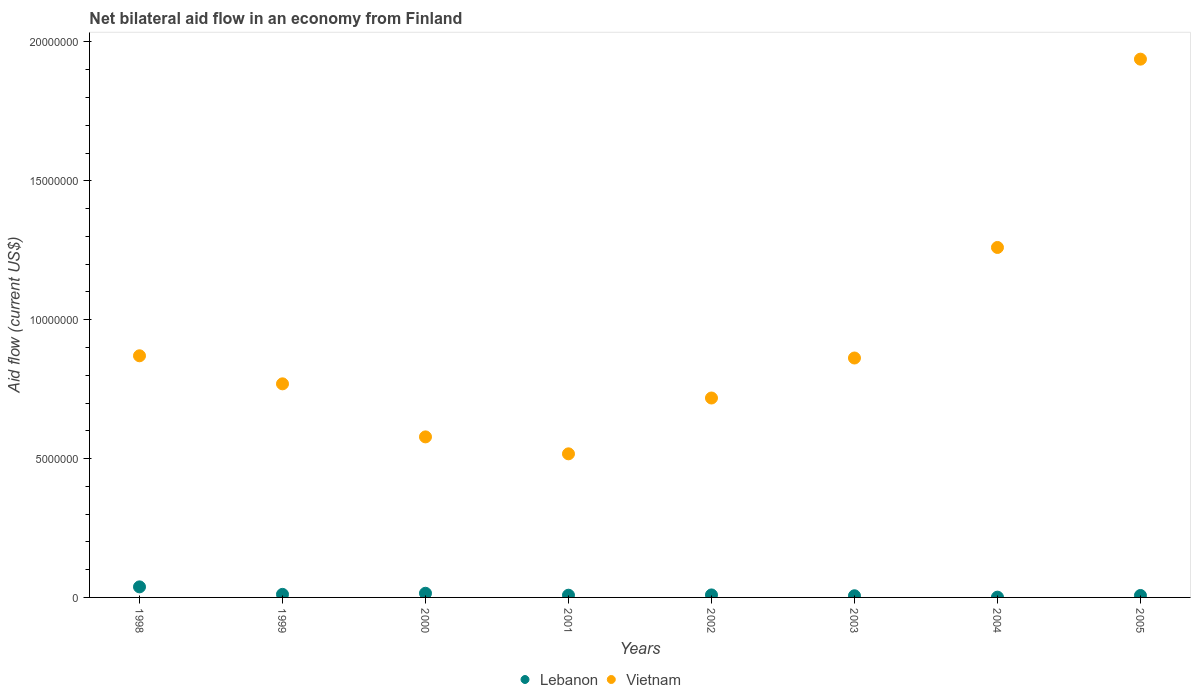How many different coloured dotlines are there?
Make the answer very short. 2. Is the number of dotlines equal to the number of legend labels?
Keep it short and to the point. Yes. What is the net bilateral aid flow in Lebanon in 1998?
Make the answer very short. 3.80e+05. Across all years, what is the maximum net bilateral aid flow in Vietnam?
Ensure brevity in your answer.  1.94e+07. What is the total net bilateral aid flow in Lebanon in the graph?
Your answer should be very brief. 9.50e+05. What is the difference between the net bilateral aid flow in Vietnam in 2001 and that in 2003?
Offer a very short reply. -3.45e+06. What is the difference between the net bilateral aid flow in Lebanon in 1998 and the net bilateral aid flow in Vietnam in 2002?
Offer a very short reply. -6.80e+06. What is the average net bilateral aid flow in Vietnam per year?
Offer a very short reply. 9.39e+06. In the year 2004, what is the difference between the net bilateral aid flow in Lebanon and net bilateral aid flow in Vietnam?
Provide a succinct answer. -1.26e+07. What is the ratio of the net bilateral aid flow in Vietnam in 1999 to that in 2005?
Ensure brevity in your answer.  0.4. Is the net bilateral aid flow in Lebanon in 1998 less than that in 2001?
Your response must be concise. No. Is the difference between the net bilateral aid flow in Lebanon in 1998 and 2001 greater than the difference between the net bilateral aid flow in Vietnam in 1998 and 2001?
Offer a terse response. No. Is the sum of the net bilateral aid flow in Vietnam in 1999 and 2003 greater than the maximum net bilateral aid flow in Lebanon across all years?
Provide a succinct answer. Yes. Is the net bilateral aid flow in Vietnam strictly greater than the net bilateral aid flow in Lebanon over the years?
Ensure brevity in your answer.  Yes. How many legend labels are there?
Offer a terse response. 2. How are the legend labels stacked?
Offer a terse response. Horizontal. What is the title of the graph?
Offer a very short reply. Net bilateral aid flow in an economy from Finland. What is the label or title of the Y-axis?
Offer a very short reply. Aid flow (current US$). What is the Aid flow (current US$) in Vietnam in 1998?
Make the answer very short. 8.70e+06. What is the Aid flow (current US$) in Lebanon in 1999?
Offer a terse response. 1.10e+05. What is the Aid flow (current US$) of Vietnam in 1999?
Provide a short and direct response. 7.69e+06. What is the Aid flow (current US$) of Lebanon in 2000?
Ensure brevity in your answer.  1.50e+05. What is the Aid flow (current US$) in Vietnam in 2000?
Ensure brevity in your answer.  5.78e+06. What is the Aid flow (current US$) of Vietnam in 2001?
Provide a succinct answer. 5.17e+06. What is the Aid flow (current US$) in Vietnam in 2002?
Offer a very short reply. 7.18e+06. What is the Aid flow (current US$) of Lebanon in 2003?
Provide a short and direct response. 6.00e+04. What is the Aid flow (current US$) of Vietnam in 2003?
Your answer should be compact. 8.62e+06. What is the Aid flow (current US$) in Lebanon in 2004?
Provide a succinct answer. 10000. What is the Aid flow (current US$) of Vietnam in 2004?
Ensure brevity in your answer.  1.26e+07. What is the Aid flow (current US$) of Vietnam in 2005?
Ensure brevity in your answer.  1.94e+07. Across all years, what is the maximum Aid flow (current US$) of Vietnam?
Give a very brief answer. 1.94e+07. Across all years, what is the minimum Aid flow (current US$) in Vietnam?
Your answer should be very brief. 5.17e+06. What is the total Aid flow (current US$) in Lebanon in the graph?
Provide a succinct answer. 9.50e+05. What is the total Aid flow (current US$) of Vietnam in the graph?
Provide a short and direct response. 7.51e+07. What is the difference between the Aid flow (current US$) in Vietnam in 1998 and that in 1999?
Your answer should be compact. 1.01e+06. What is the difference between the Aid flow (current US$) in Vietnam in 1998 and that in 2000?
Offer a very short reply. 2.92e+06. What is the difference between the Aid flow (current US$) of Lebanon in 1998 and that in 2001?
Offer a terse response. 3.00e+05. What is the difference between the Aid flow (current US$) in Vietnam in 1998 and that in 2001?
Ensure brevity in your answer.  3.53e+06. What is the difference between the Aid flow (current US$) of Lebanon in 1998 and that in 2002?
Offer a terse response. 2.90e+05. What is the difference between the Aid flow (current US$) of Vietnam in 1998 and that in 2002?
Provide a succinct answer. 1.52e+06. What is the difference between the Aid flow (current US$) of Lebanon in 1998 and that in 2003?
Give a very brief answer. 3.20e+05. What is the difference between the Aid flow (current US$) in Vietnam in 1998 and that in 2003?
Make the answer very short. 8.00e+04. What is the difference between the Aid flow (current US$) in Vietnam in 1998 and that in 2004?
Your answer should be compact. -3.90e+06. What is the difference between the Aid flow (current US$) of Lebanon in 1998 and that in 2005?
Your answer should be compact. 3.10e+05. What is the difference between the Aid flow (current US$) in Vietnam in 1998 and that in 2005?
Your response must be concise. -1.07e+07. What is the difference between the Aid flow (current US$) of Vietnam in 1999 and that in 2000?
Your response must be concise. 1.91e+06. What is the difference between the Aid flow (current US$) in Lebanon in 1999 and that in 2001?
Your response must be concise. 3.00e+04. What is the difference between the Aid flow (current US$) of Vietnam in 1999 and that in 2001?
Make the answer very short. 2.52e+06. What is the difference between the Aid flow (current US$) in Lebanon in 1999 and that in 2002?
Keep it short and to the point. 2.00e+04. What is the difference between the Aid flow (current US$) of Vietnam in 1999 and that in 2002?
Your answer should be very brief. 5.10e+05. What is the difference between the Aid flow (current US$) in Lebanon in 1999 and that in 2003?
Make the answer very short. 5.00e+04. What is the difference between the Aid flow (current US$) of Vietnam in 1999 and that in 2003?
Your answer should be compact. -9.30e+05. What is the difference between the Aid flow (current US$) in Vietnam in 1999 and that in 2004?
Provide a short and direct response. -4.91e+06. What is the difference between the Aid flow (current US$) in Lebanon in 1999 and that in 2005?
Provide a succinct answer. 4.00e+04. What is the difference between the Aid flow (current US$) in Vietnam in 1999 and that in 2005?
Offer a terse response. -1.17e+07. What is the difference between the Aid flow (current US$) in Vietnam in 2000 and that in 2001?
Give a very brief answer. 6.10e+05. What is the difference between the Aid flow (current US$) in Lebanon in 2000 and that in 2002?
Provide a short and direct response. 6.00e+04. What is the difference between the Aid flow (current US$) in Vietnam in 2000 and that in 2002?
Keep it short and to the point. -1.40e+06. What is the difference between the Aid flow (current US$) in Lebanon in 2000 and that in 2003?
Provide a short and direct response. 9.00e+04. What is the difference between the Aid flow (current US$) in Vietnam in 2000 and that in 2003?
Your answer should be compact. -2.84e+06. What is the difference between the Aid flow (current US$) of Lebanon in 2000 and that in 2004?
Make the answer very short. 1.40e+05. What is the difference between the Aid flow (current US$) in Vietnam in 2000 and that in 2004?
Provide a short and direct response. -6.82e+06. What is the difference between the Aid flow (current US$) of Vietnam in 2000 and that in 2005?
Your answer should be very brief. -1.36e+07. What is the difference between the Aid flow (current US$) of Lebanon in 2001 and that in 2002?
Ensure brevity in your answer.  -10000. What is the difference between the Aid flow (current US$) in Vietnam in 2001 and that in 2002?
Ensure brevity in your answer.  -2.01e+06. What is the difference between the Aid flow (current US$) of Vietnam in 2001 and that in 2003?
Your answer should be very brief. -3.45e+06. What is the difference between the Aid flow (current US$) in Lebanon in 2001 and that in 2004?
Keep it short and to the point. 7.00e+04. What is the difference between the Aid flow (current US$) in Vietnam in 2001 and that in 2004?
Keep it short and to the point. -7.43e+06. What is the difference between the Aid flow (current US$) in Vietnam in 2001 and that in 2005?
Give a very brief answer. -1.42e+07. What is the difference between the Aid flow (current US$) in Lebanon in 2002 and that in 2003?
Provide a short and direct response. 3.00e+04. What is the difference between the Aid flow (current US$) in Vietnam in 2002 and that in 2003?
Provide a short and direct response. -1.44e+06. What is the difference between the Aid flow (current US$) in Vietnam in 2002 and that in 2004?
Your response must be concise. -5.42e+06. What is the difference between the Aid flow (current US$) in Vietnam in 2002 and that in 2005?
Keep it short and to the point. -1.22e+07. What is the difference between the Aid flow (current US$) of Lebanon in 2003 and that in 2004?
Your response must be concise. 5.00e+04. What is the difference between the Aid flow (current US$) of Vietnam in 2003 and that in 2004?
Your answer should be very brief. -3.98e+06. What is the difference between the Aid flow (current US$) in Lebanon in 2003 and that in 2005?
Ensure brevity in your answer.  -10000. What is the difference between the Aid flow (current US$) in Vietnam in 2003 and that in 2005?
Offer a very short reply. -1.08e+07. What is the difference between the Aid flow (current US$) in Lebanon in 2004 and that in 2005?
Offer a terse response. -6.00e+04. What is the difference between the Aid flow (current US$) of Vietnam in 2004 and that in 2005?
Make the answer very short. -6.78e+06. What is the difference between the Aid flow (current US$) in Lebanon in 1998 and the Aid flow (current US$) in Vietnam in 1999?
Give a very brief answer. -7.31e+06. What is the difference between the Aid flow (current US$) of Lebanon in 1998 and the Aid flow (current US$) of Vietnam in 2000?
Offer a very short reply. -5.40e+06. What is the difference between the Aid flow (current US$) of Lebanon in 1998 and the Aid flow (current US$) of Vietnam in 2001?
Your answer should be compact. -4.79e+06. What is the difference between the Aid flow (current US$) in Lebanon in 1998 and the Aid flow (current US$) in Vietnam in 2002?
Give a very brief answer. -6.80e+06. What is the difference between the Aid flow (current US$) of Lebanon in 1998 and the Aid flow (current US$) of Vietnam in 2003?
Your response must be concise. -8.24e+06. What is the difference between the Aid flow (current US$) in Lebanon in 1998 and the Aid flow (current US$) in Vietnam in 2004?
Your response must be concise. -1.22e+07. What is the difference between the Aid flow (current US$) of Lebanon in 1998 and the Aid flow (current US$) of Vietnam in 2005?
Ensure brevity in your answer.  -1.90e+07. What is the difference between the Aid flow (current US$) in Lebanon in 1999 and the Aid flow (current US$) in Vietnam in 2000?
Make the answer very short. -5.67e+06. What is the difference between the Aid flow (current US$) of Lebanon in 1999 and the Aid flow (current US$) of Vietnam in 2001?
Make the answer very short. -5.06e+06. What is the difference between the Aid flow (current US$) in Lebanon in 1999 and the Aid flow (current US$) in Vietnam in 2002?
Keep it short and to the point. -7.07e+06. What is the difference between the Aid flow (current US$) of Lebanon in 1999 and the Aid flow (current US$) of Vietnam in 2003?
Give a very brief answer. -8.51e+06. What is the difference between the Aid flow (current US$) in Lebanon in 1999 and the Aid flow (current US$) in Vietnam in 2004?
Make the answer very short. -1.25e+07. What is the difference between the Aid flow (current US$) in Lebanon in 1999 and the Aid flow (current US$) in Vietnam in 2005?
Make the answer very short. -1.93e+07. What is the difference between the Aid flow (current US$) in Lebanon in 2000 and the Aid flow (current US$) in Vietnam in 2001?
Give a very brief answer. -5.02e+06. What is the difference between the Aid flow (current US$) of Lebanon in 2000 and the Aid flow (current US$) of Vietnam in 2002?
Offer a very short reply. -7.03e+06. What is the difference between the Aid flow (current US$) of Lebanon in 2000 and the Aid flow (current US$) of Vietnam in 2003?
Keep it short and to the point. -8.47e+06. What is the difference between the Aid flow (current US$) in Lebanon in 2000 and the Aid flow (current US$) in Vietnam in 2004?
Your response must be concise. -1.24e+07. What is the difference between the Aid flow (current US$) in Lebanon in 2000 and the Aid flow (current US$) in Vietnam in 2005?
Ensure brevity in your answer.  -1.92e+07. What is the difference between the Aid flow (current US$) of Lebanon in 2001 and the Aid flow (current US$) of Vietnam in 2002?
Your response must be concise. -7.10e+06. What is the difference between the Aid flow (current US$) of Lebanon in 2001 and the Aid flow (current US$) of Vietnam in 2003?
Keep it short and to the point. -8.54e+06. What is the difference between the Aid flow (current US$) in Lebanon in 2001 and the Aid flow (current US$) in Vietnam in 2004?
Provide a short and direct response. -1.25e+07. What is the difference between the Aid flow (current US$) in Lebanon in 2001 and the Aid flow (current US$) in Vietnam in 2005?
Make the answer very short. -1.93e+07. What is the difference between the Aid flow (current US$) in Lebanon in 2002 and the Aid flow (current US$) in Vietnam in 2003?
Your answer should be very brief. -8.53e+06. What is the difference between the Aid flow (current US$) in Lebanon in 2002 and the Aid flow (current US$) in Vietnam in 2004?
Provide a short and direct response. -1.25e+07. What is the difference between the Aid flow (current US$) in Lebanon in 2002 and the Aid flow (current US$) in Vietnam in 2005?
Offer a very short reply. -1.93e+07. What is the difference between the Aid flow (current US$) in Lebanon in 2003 and the Aid flow (current US$) in Vietnam in 2004?
Keep it short and to the point. -1.25e+07. What is the difference between the Aid flow (current US$) in Lebanon in 2003 and the Aid flow (current US$) in Vietnam in 2005?
Your answer should be compact. -1.93e+07. What is the difference between the Aid flow (current US$) of Lebanon in 2004 and the Aid flow (current US$) of Vietnam in 2005?
Your response must be concise. -1.94e+07. What is the average Aid flow (current US$) in Lebanon per year?
Your response must be concise. 1.19e+05. What is the average Aid flow (current US$) of Vietnam per year?
Offer a very short reply. 9.39e+06. In the year 1998, what is the difference between the Aid flow (current US$) of Lebanon and Aid flow (current US$) of Vietnam?
Give a very brief answer. -8.32e+06. In the year 1999, what is the difference between the Aid flow (current US$) of Lebanon and Aid flow (current US$) of Vietnam?
Ensure brevity in your answer.  -7.58e+06. In the year 2000, what is the difference between the Aid flow (current US$) in Lebanon and Aid flow (current US$) in Vietnam?
Your answer should be compact. -5.63e+06. In the year 2001, what is the difference between the Aid flow (current US$) in Lebanon and Aid flow (current US$) in Vietnam?
Provide a succinct answer. -5.09e+06. In the year 2002, what is the difference between the Aid flow (current US$) in Lebanon and Aid flow (current US$) in Vietnam?
Offer a terse response. -7.09e+06. In the year 2003, what is the difference between the Aid flow (current US$) of Lebanon and Aid flow (current US$) of Vietnam?
Keep it short and to the point. -8.56e+06. In the year 2004, what is the difference between the Aid flow (current US$) in Lebanon and Aid flow (current US$) in Vietnam?
Your answer should be compact. -1.26e+07. In the year 2005, what is the difference between the Aid flow (current US$) in Lebanon and Aid flow (current US$) in Vietnam?
Ensure brevity in your answer.  -1.93e+07. What is the ratio of the Aid flow (current US$) of Lebanon in 1998 to that in 1999?
Offer a very short reply. 3.45. What is the ratio of the Aid flow (current US$) of Vietnam in 1998 to that in 1999?
Your answer should be very brief. 1.13. What is the ratio of the Aid flow (current US$) of Lebanon in 1998 to that in 2000?
Offer a very short reply. 2.53. What is the ratio of the Aid flow (current US$) in Vietnam in 1998 to that in 2000?
Give a very brief answer. 1.51. What is the ratio of the Aid flow (current US$) in Lebanon in 1998 to that in 2001?
Offer a terse response. 4.75. What is the ratio of the Aid flow (current US$) in Vietnam in 1998 to that in 2001?
Offer a terse response. 1.68. What is the ratio of the Aid flow (current US$) in Lebanon in 1998 to that in 2002?
Provide a short and direct response. 4.22. What is the ratio of the Aid flow (current US$) of Vietnam in 1998 to that in 2002?
Give a very brief answer. 1.21. What is the ratio of the Aid flow (current US$) in Lebanon in 1998 to that in 2003?
Your response must be concise. 6.33. What is the ratio of the Aid flow (current US$) in Vietnam in 1998 to that in 2003?
Provide a succinct answer. 1.01. What is the ratio of the Aid flow (current US$) of Lebanon in 1998 to that in 2004?
Offer a terse response. 38. What is the ratio of the Aid flow (current US$) of Vietnam in 1998 to that in 2004?
Provide a succinct answer. 0.69. What is the ratio of the Aid flow (current US$) in Lebanon in 1998 to that in 2005?
Your response must be concise. 5.43. What is the ratio of the Aid flow (current US$) of Vietnam in 1998 to that in 2005?
Keep it short and to the point. 0.45. What is the ratio of the Aid flow (current US$) in Lebanon in 1999 to that in 2000?
Your response must be concise. 0.73. What is the ratio of the Aid flow (current US$) in Vietnam in 1999 to that in 2000?
Provide a short and direct response. 1.33. What is the ratio of the Aid flow (current US$) in Lebanon in 1999 to that in 2001?
Ensure brevity in your answer.  1.38. What is the ratio of the Aid flow (current US$) in Vietnam in 1999 to that in 2001?
Your answer should be very brief. 1.49. What is the ratio of the Aid flow (current US$) of Lebanon in 1999 to that in 2002?
Offer a terse response. 1.22. What is the ratio of the Aid flow (current US$) of Vietnam in 1999 to that in 2002?
Offer a terse response. 1.07. What is the ratio of the Aid flow (current US$) of Lebanon in 1999 to that in 2003?
Provide a succinct answer. 1.83. What is the ratio of the Aid flow (current US$) in Vietnam in 1999 to that in 2003?
Provide a succinct answer. 0.89. What is the ratio of the Aid flow (current US$) in Lebanon in 1999 to that in 2004?
Keep it short and to the point. 11. What is the ratio of the Aid flow (current US$) of Vietnam in 1999 to that in 2004?
Offer a terse response. 0.61. What is the ratio of the Aid flow (current US$) of Lebanon in 1999 to that in 2005?
Ensure brevity in your answer.  1.57. What is the ratio of the Aid flow (current US$) of Vietnam in 1999 to that in 2005?
Make the answer very short. 0.4. What is the ratio of the Aid flow (current US$) of Lebanon in 2000 to that in 2001?
Your response must be concise. 1.88. What is the ratio of the Aid flow (current US$) in Vietnam in 2000 to that in 2001?
Keep it short and to the point. 1.12. What is the ratio of the Aid flow (current US$) in Lebanon in 2000 to that in 2002?
Make the answer very short. 1.67. What is the ratio of the Aid flow (current US$) in Vietnam in 2000 to that in 2002?
Your response must be concise. 0.81. What is the ratio of the Aid flow (current US$) in Vietnam in 2000 to that in 2003?
Your response must be concise. 0.67. What is the ratio of the Aid flow (current US$) of Vietnam in 2000 to that in 2004?
Your answer should be very brief. 0.46. What is the ratio of the Aid flow (current US$) in Lebanon in 2000 to that in 2005?
Ensure brevity in your answer.  2.14. What is the ratio of the Aid flow (current US$) in Vietnam in 2000 to that in 2005?
Offer a very short reply. 0.3. What is the ratio of the Aid flow (current US$) of Vietnam in 2001 to that in 2002?
Offer a very short reply. 0.72. What is the ratio of the Aid flow (current US$) in Lebanon in 2001 to that in 2003?
Offer a very short reply. 1.33. What is the ratio of the Aid flow (current US$) in Vietnam in 2001 to that in 2003?
Offer a terse response. 0.6. What is the ratio of the Aid flow (current US$) of Vietnam in 2001 to that in 2004?
Ensure brevity in your answer.  0.41. What is the ratio of the Aid flow (current US$) of Lebanon in 2001 to that in 2005?
Provide a succinct answer. 1.14. What is the ratio of the Aid flow (current US$) in Vietnam in 2001 to that in 2005?
Make the answer very short. 0.27. What is the ratio of the Aid flow (current US$) of Lebanon in 2002 to that in 2003?
Keep it short and to the point. 1.5. What is the ratio of the Aid flow (current US$) of Vietnam in 2002 to that in 2003?
Your answer should be compact. 0.83. What is the ratio of the Aid flow (current US$) of Lebanon in 2002 to that in 2004?
Your answer should be compact. 9. What is the ratio of the Aid flow (current US$) in Vietnam in 2002 to that in 2004?
Make the answer very short. 0.57. What is the ratio of the Aid flow (current US$) in Vietnam in 2002 to that in 2005?
Offer a very short reply. 0.37. What is the ratio of the Aid flow (current US$) in Vietnam in 2003 to that in 2004?
Provide a succinct answer. 0.68. What is the ratio of the Aid flow (current US$) of Vietnam in 2003 to that in 2005?
Your answer should be very brief. 0.44. What is the ratio of the Aid flow (current US$) of Lebanon in 2004 to that in 2005?
Your answer should be very brief. 0.14. What is the ratio of the Aid flow (current US$) of Vietnam in 2004 to that in 2005?
Your answer should be very brief. 0.65. What is the difference between the highest and the second highest Aid flow (current US$) in Lebanon?
Keep it short and to the point. 2.30e+05. What is the difference between the highest and the second highest Aid flow (current US$) in Vietnam?
Ensure brevity in your answer.  6.78e+06. What is the difference between the highest and the lowest Aid flow (current US$) in Lebanon?
Offer a terse response. 3.70e+05. What is the difference between the highest and the lowest Aid flow (current US$) of Vietnam?
Give a very brief answer. 1.42e+07. 